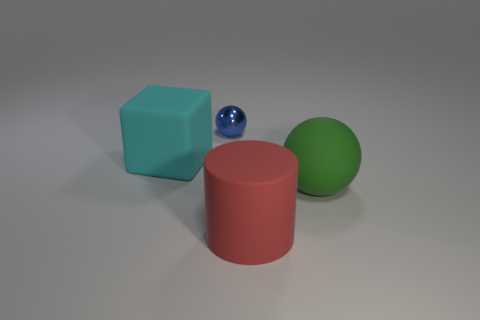Subtract all green spheres. How many spheres are left? 1 Subtract 1 cubes. How many cubes are left? 0 Add 4 big rubber things. How many objects exist? 8 Subtract all blocks. How many objects are left? 3 Subtract all red cylinders. How many blue balls are left? 1 Subtract all big cyan cubes. Subtract all large cubes. How many objects are left? 2 Add 2 rubber cylinders. How many rubber cylinders are left? 3 Add 1 small cyan spheres. How many small cyan spheres exist? 1 Subtract 0 purple balls. How many objects are left? 4 Subtract all purple spheres. Subtract all green cubes. How many spheres are left? 2 